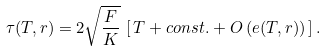<formula> <loc_0><loc_0><loc_500><loc_500>\tau ( T , r ) = 2 \sqrt { \frac { F } { K } } \, \left [ \, T + c o n s t . + { O } \left ( e ( T , r ) \right ) \, \right ] .</formula> 